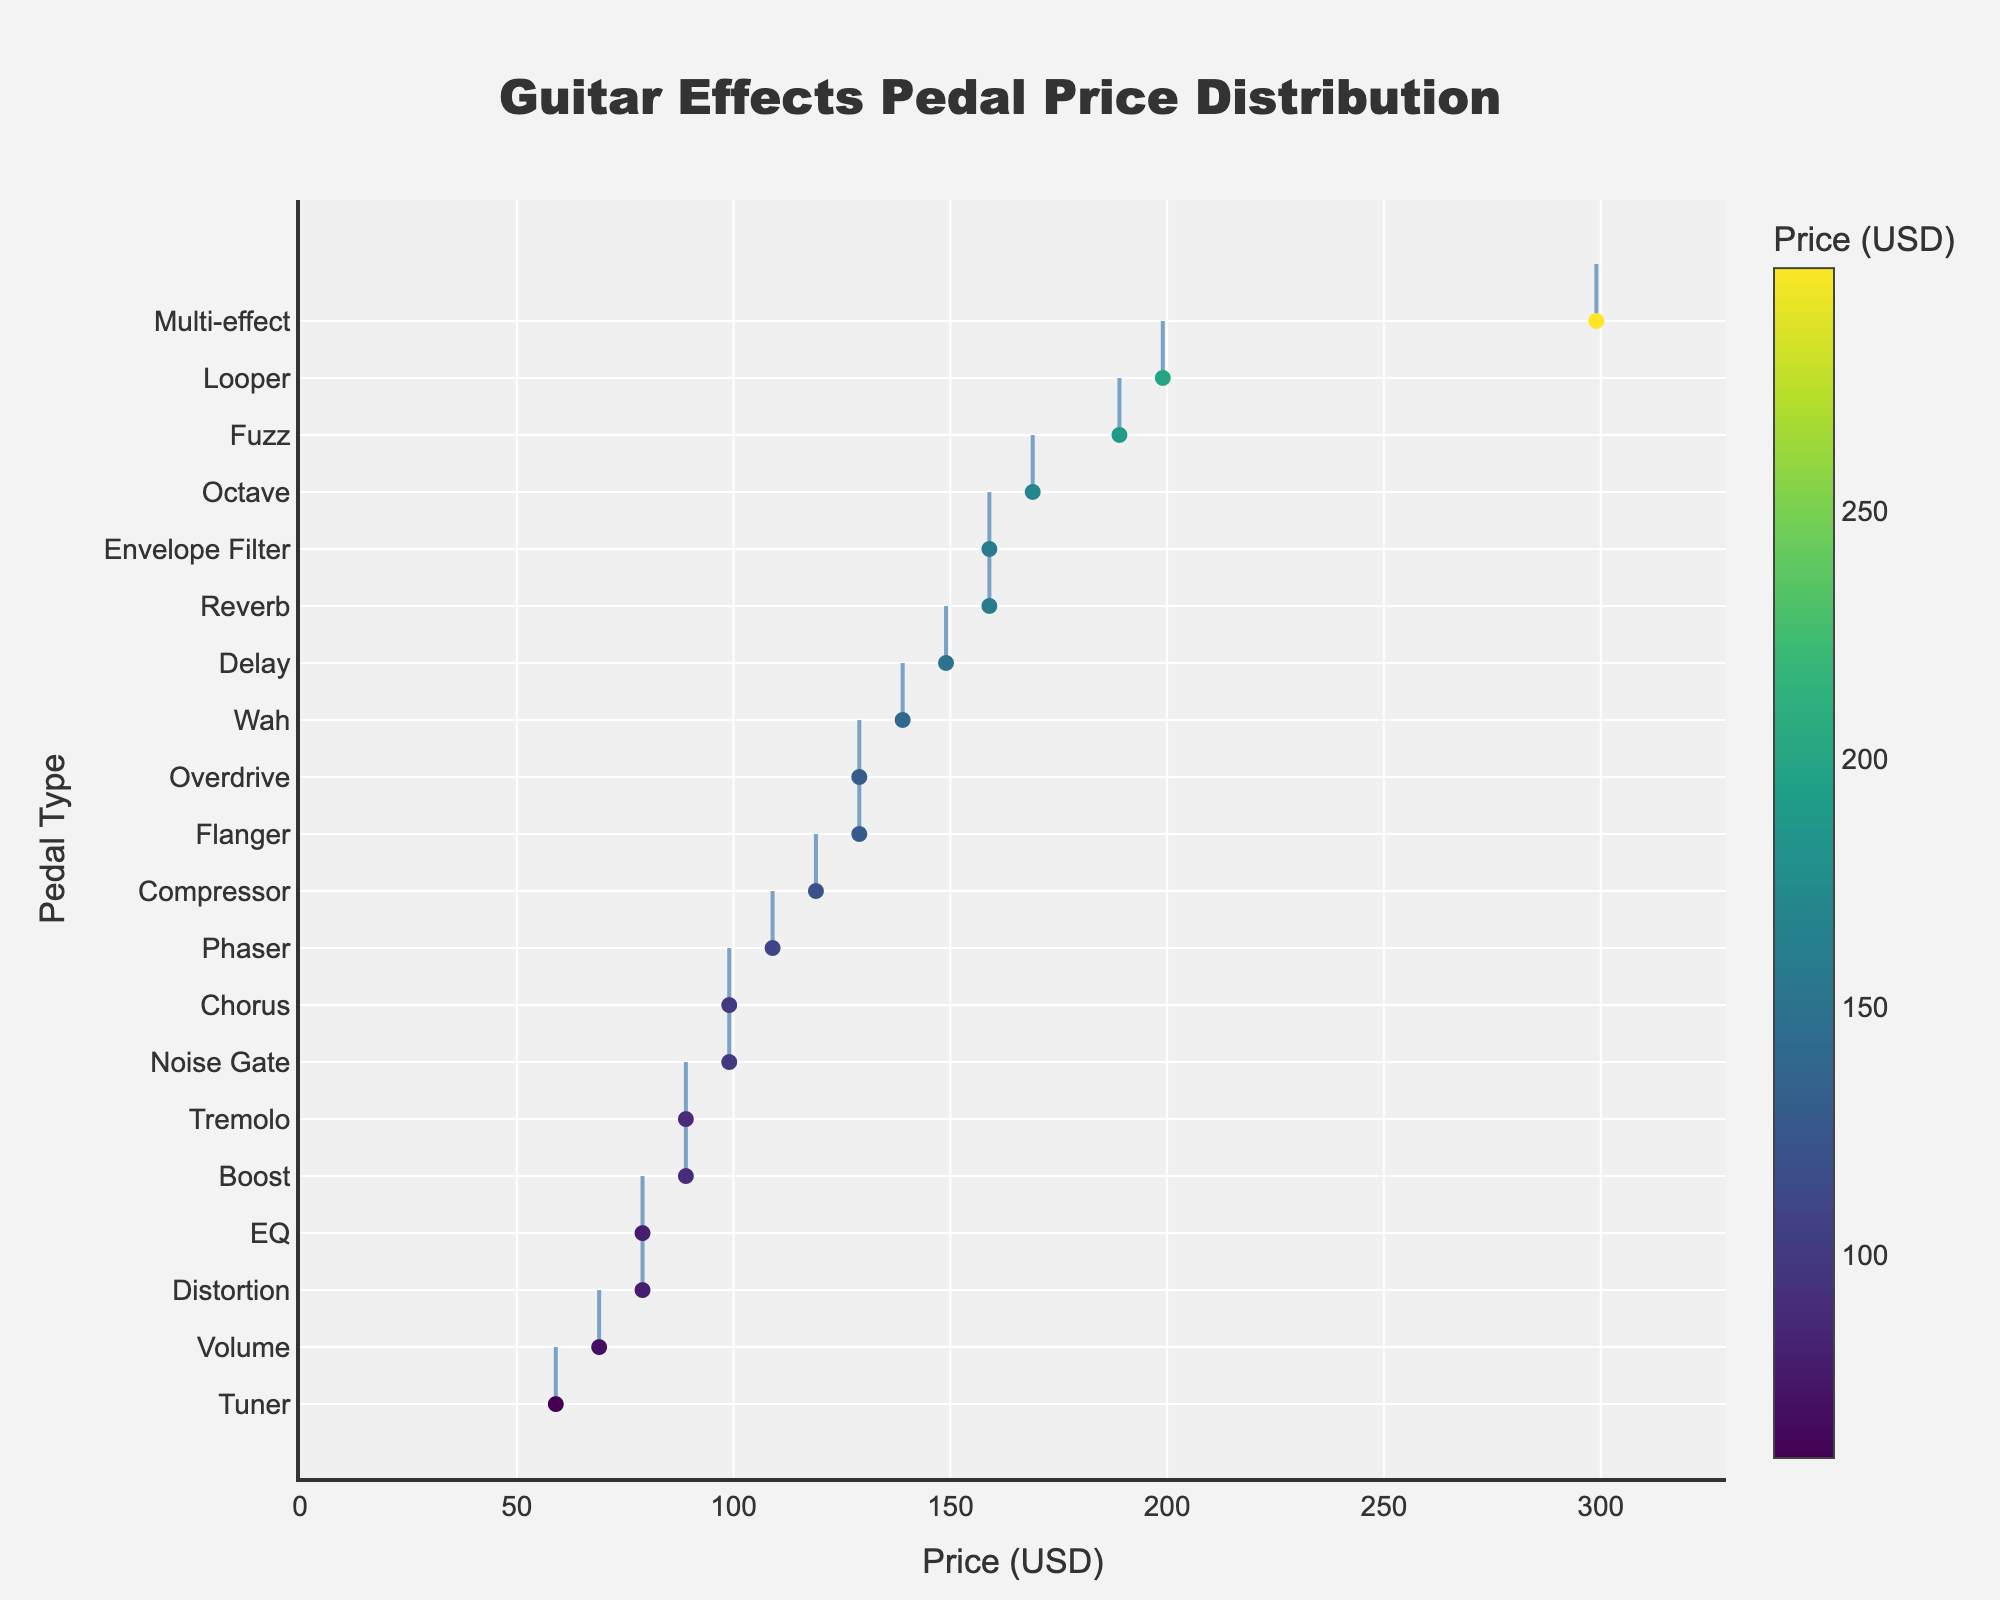What is the highest price among the guitar effects pedals? By looking at the longest horizontal line in the density plot, you can identify the pedal with the highest price.
Answer: 299 USD Which pedal type has the lowest price? Find the shortest horizontal line in the density plot; the associated pedal type will have the lowest price.
Answer: Tuner What is the most common price range for guitar effects pedals? Observe the density plot area with the highest concentration of lines to determine where most pedal prices fall.
Answer: 59 - 199 USD Which pedal type is priced at 199 USD? Identify the point on the price axis at 199 USD and follow it horizontally to find the associated pedal type.
Answer: Looper Compare the prices of the Overdrive and Reverb pedals. Which one is more expensive? Locate the price points for Overdrive (129 USD) and Reverb (159 USD) on the plot. Compare the two values to see which one is higher.
Answer: Reverb is more expensive What is the price of the Compressor pedal? Look for the marker on the plot that matches the name "Compressor" and read the associated price value.
Answer: 119 USD Calculate the average price of the Distortion and Boost pedals. Identify the prices for Distortion (79 USD) and Boost (89 USD), sum them up (79 + 89 = 168), and divide by 2 to find the average.
Answer: 84 USD Which price range contains the fewest pedal types? Look for the sparsest region in the density plot to identify the price range with the least number of pedal types.
Answer: Above 200 USD How many pedal types are priced below 100 USD? Count the number of pedal types (markers) located to the left of the 100 USD mark on the plot.
Answer: 7 types (Distortion, Chorus, Tremolo, Tuner, Boost, EQ, Volume) Do Fuzz and Octave pedals have similar prices? Locate the price markers for Fuzz (189 USD) and Octave (169 USD) and compare their positions to see how close they are on the price axis.
Answer: No, Fuzz is slightly more expensive 